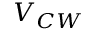Convert formula to latex. <formula><loc_0><loc_0><loc_500><loc_500>V _ { C W }</formula> 